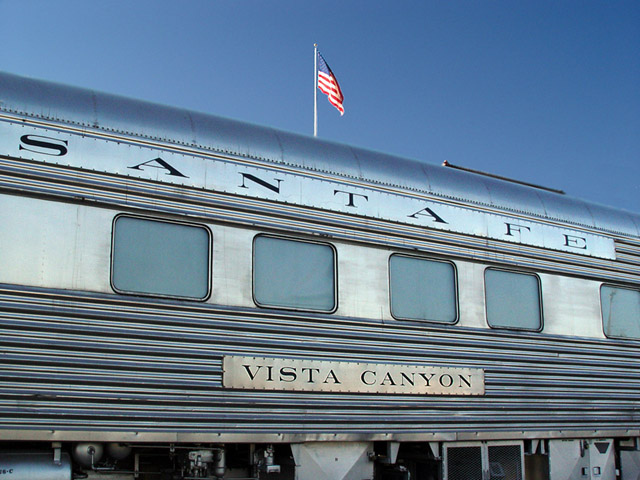<image>What portion of a public transportation vehicle does this resemble? It is uncertain what portion of a public transportation vehicle this resembles. It could be a train, subway, or commuter train. What portion of a public transportation vehicle does this resemble? It is ambiguous what portion of a public transportation vehicle this resembles. It can be a train, seating, subway, or train car. 